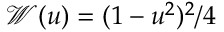<formula> <loc_0><loc_0><loc_500><loc_500>\mathcal { W } ( u ) = ( 1 - u ^ { 2 } ) ^ { 2 } / 4</formula> 